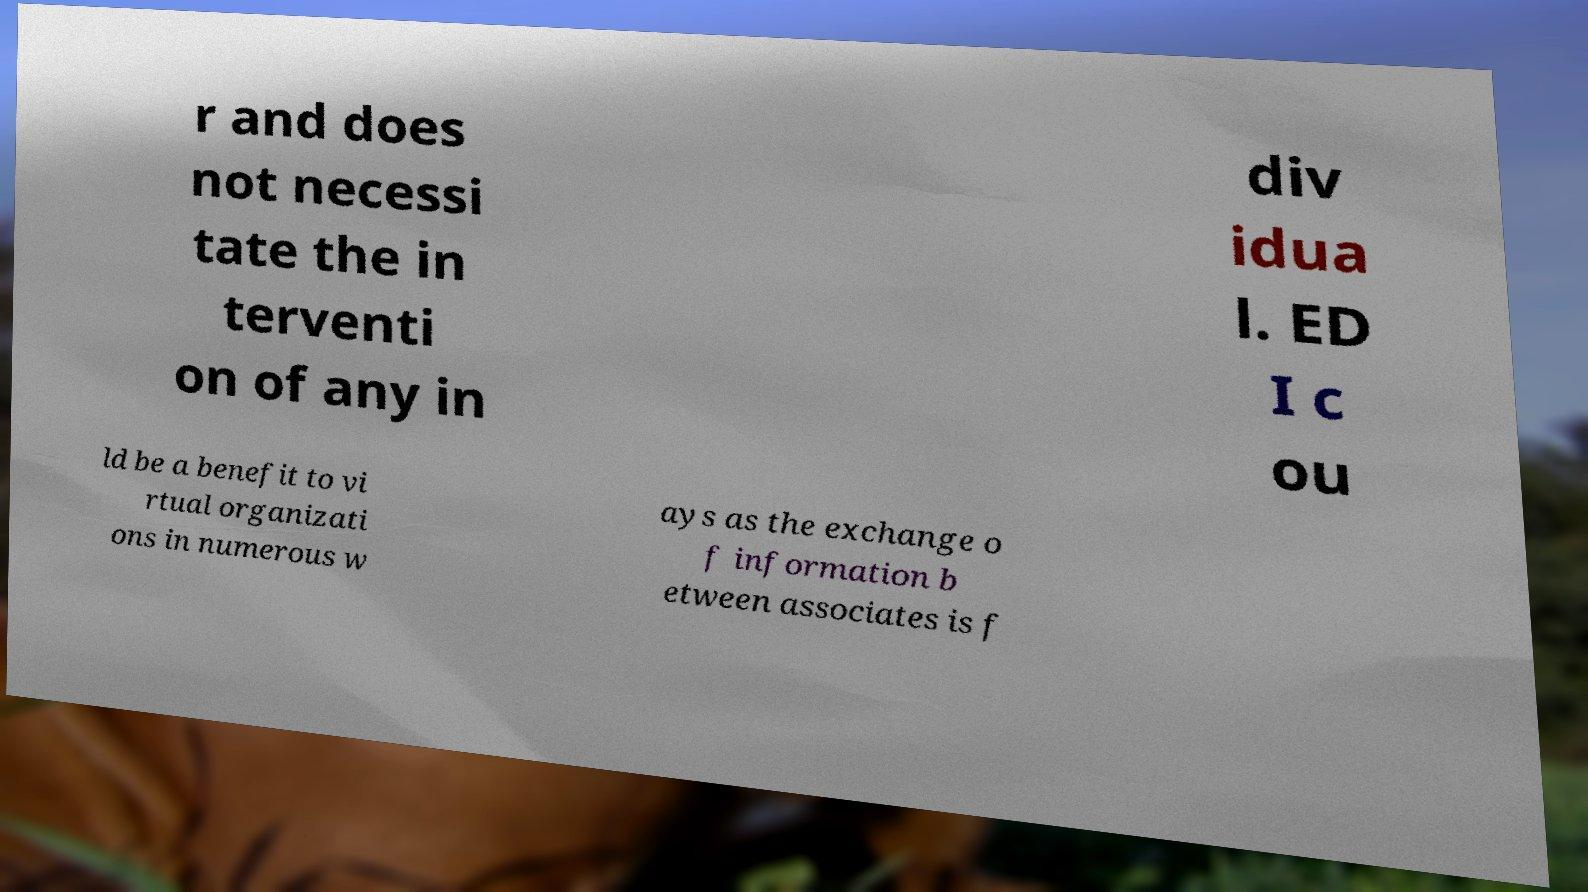Please read and relay the text visible in this image. What does it say? r and does not necessi tate the in terventi on of any in div idua l. ED I c ou ld be a benefit to vi rtual organizati ons in numerous w ays as the exchange o f information b etween associates is f 